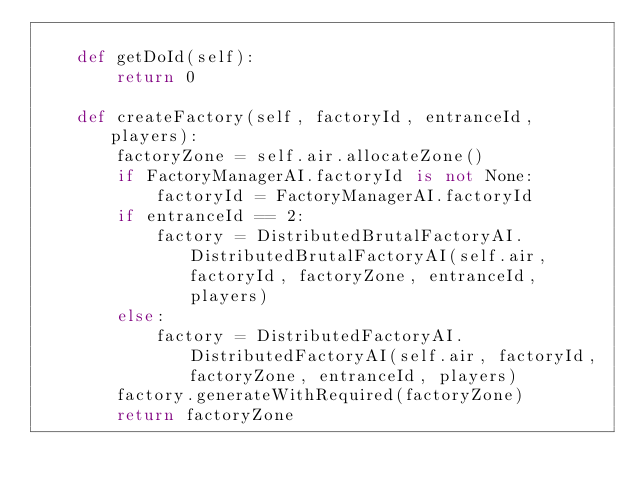Convert code to text. <code><loc_0><loc_0><loc_500><loc_500><_Python_>
    def getDoId(self):
        return 0

    def createFactory(self, factoryId, entranceId, players):
        factoryZone = self.air.allocateZone()
        if FactoryManagerAI.factoryId is not None:
            factoryId = FactoryManagerAI.factoryId
        if entranceId == 2:
            factory = DistributedBrutalFactoryAI.DistributedBrutalFactoryAI(self.air, factoryId, factoryZone, entranceId, players)
        else:    
            factory = DistributedFactoryAI.DistributedFactoryAI(self.air, factoryId, factoryZone, entranceId, players)
        factory.generateWithRequired(factoryZone)
        return factoryZone
</code> 